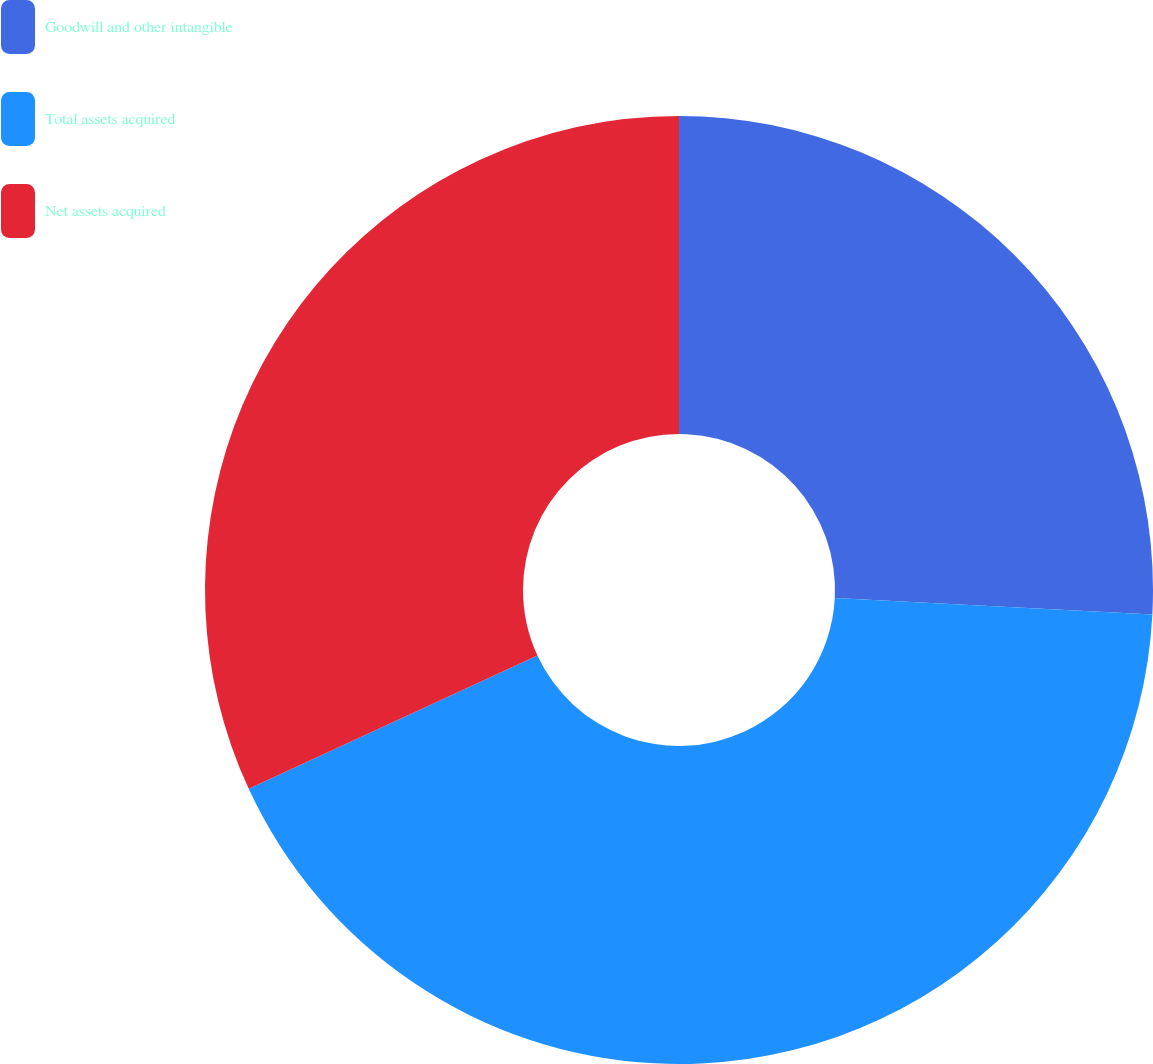Convert chart. <chart><loc_0><loc_0><loc_500><loc_500><pie_chart><fcel>Goodwill and other intangible<fcel>Total assets acquired<fcel>Net assets acquired<nl><fcel>25.82%<fcel>42.29%<fcel>31.89%<nl></chart> 